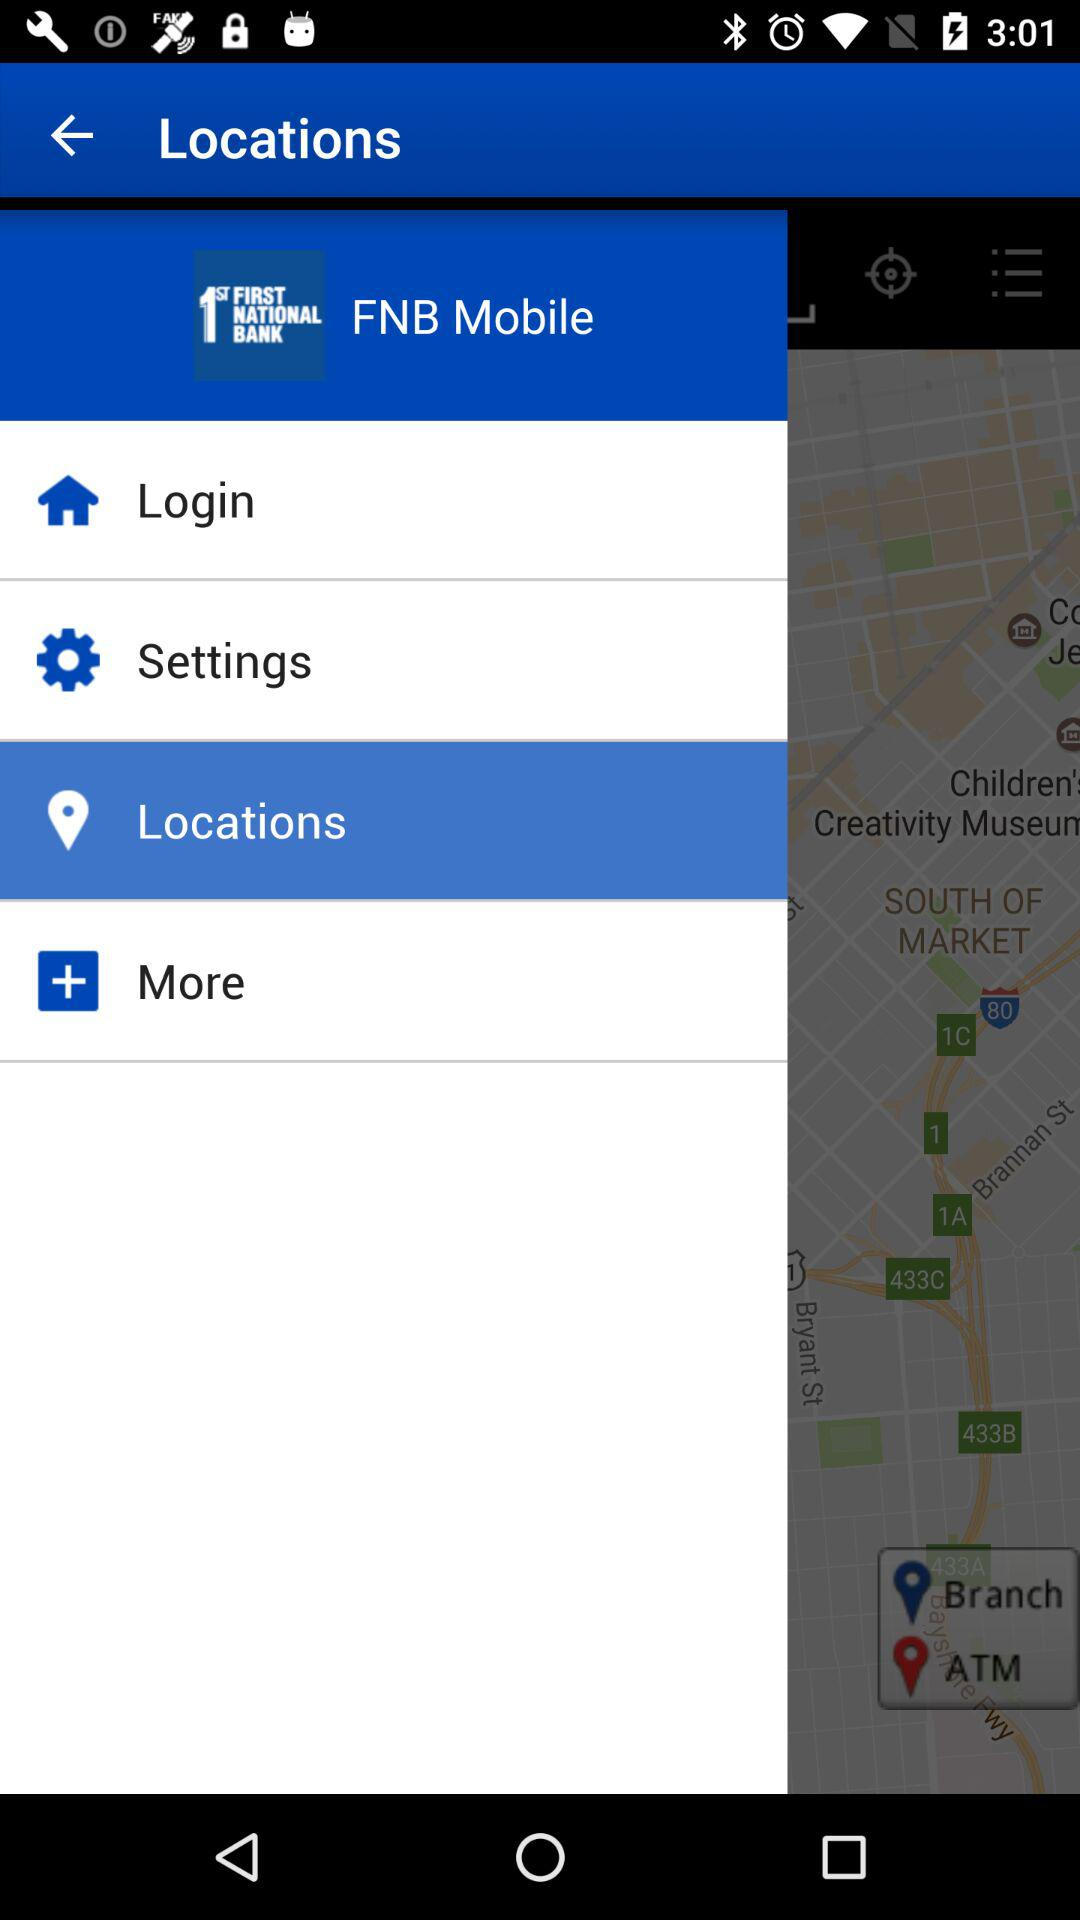How many locations are on the map?
Answer the question using a single word or phrase. 2 